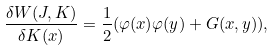Convert formula to latex. <formula><loc_0><loc_0><loc_500><loc_500>\frac { \delta W ( J , K ) } { \delta K ( x ) } = \frac { 1 } { 2 } ( \varphi ( x ) \varphi ( y ) + G ( x , y ) ) ,</formula> 